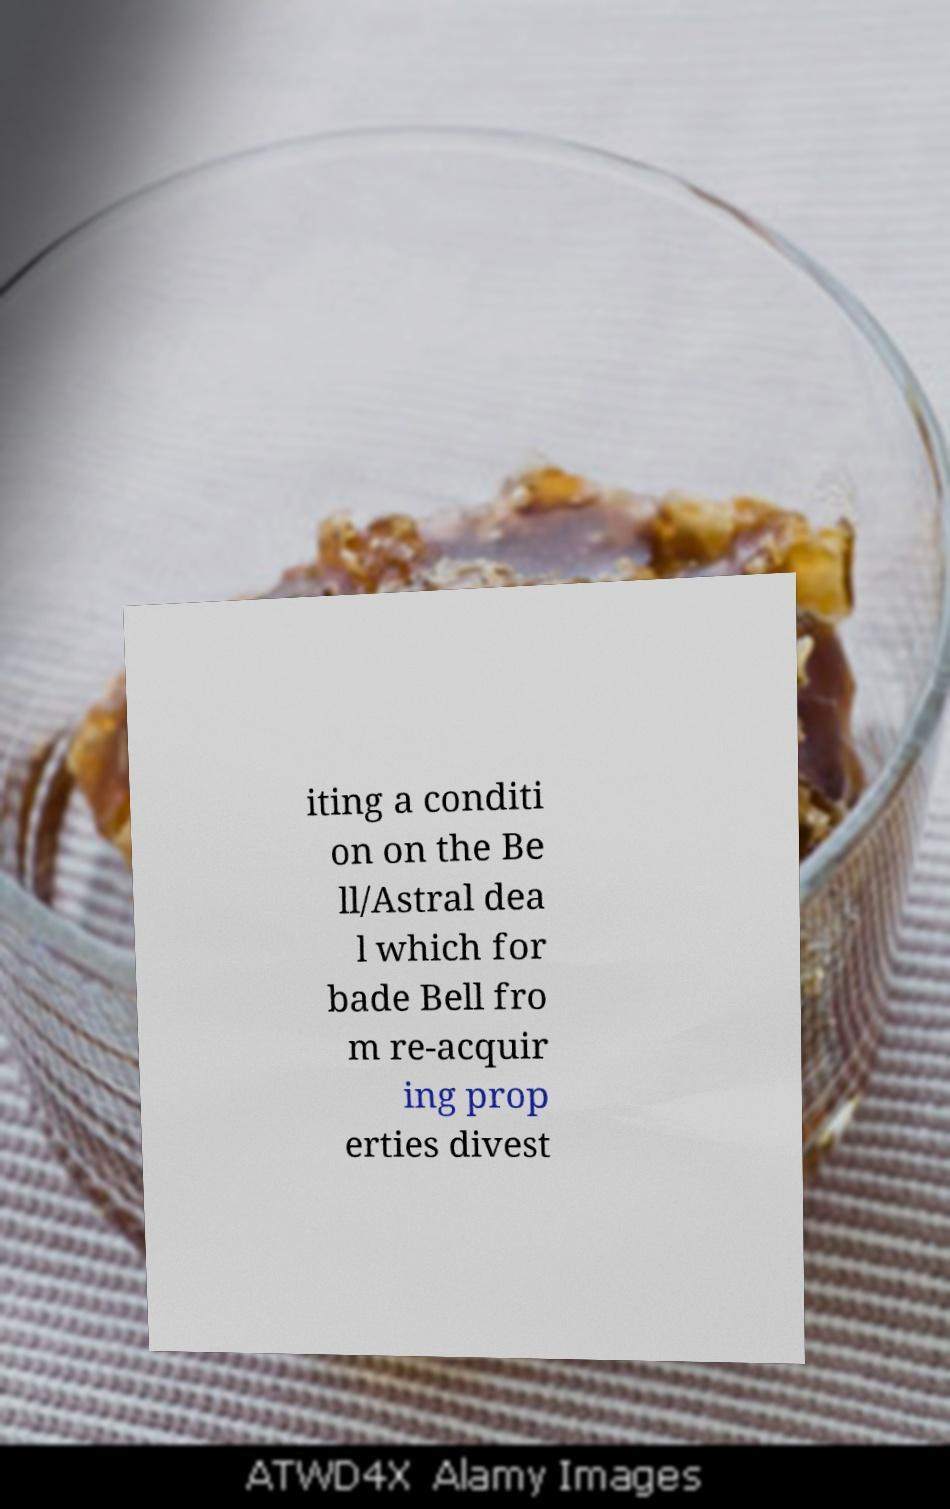For documentation purposes, I need the text within this image transcribed. Could you provide that? iting a conditi on on the Be ll/Astral dea l which for bade Bell fro m re-acquir ing prop erties divest 